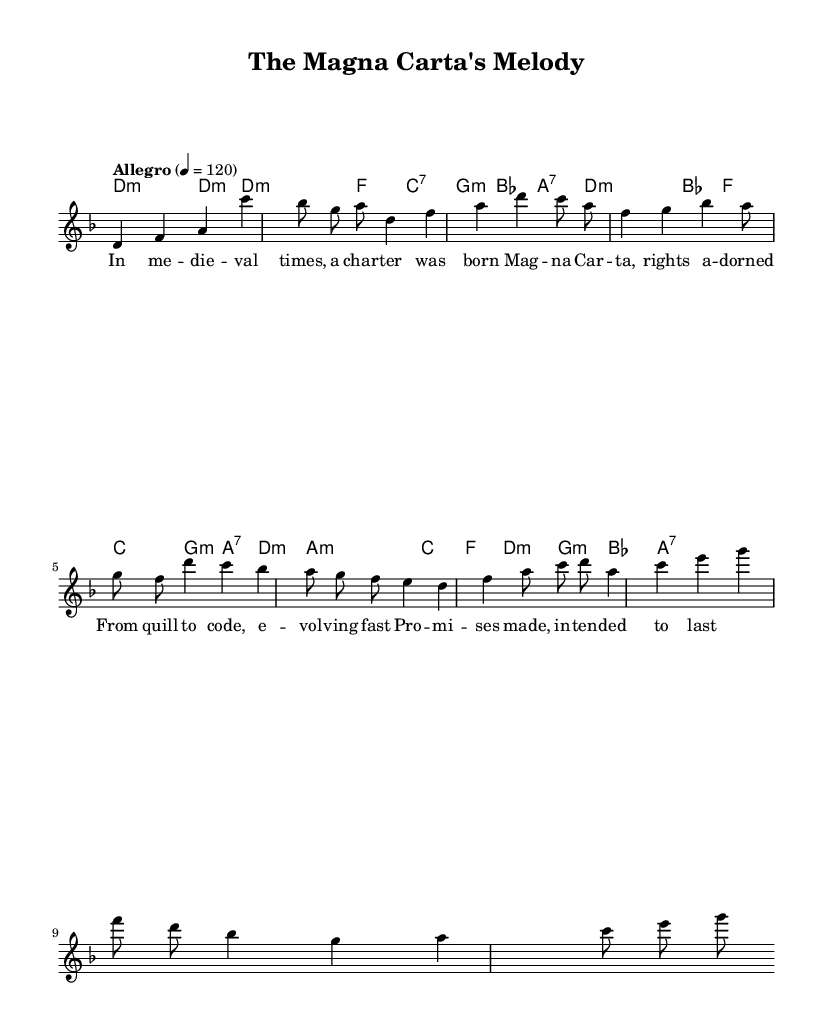What is the key signature of this music? The key signature is indicated at the beginning of the score, showing one flat, which corresponds to D minor.
Answer: D minor What is the time signature of the piece? The time signature is displayed near the beginning, indicating the piece is in a 7/8 time signature.
Answer: 7/8 What is the tempo marking for the music? The tempo marking shows that the piece should be played "Allegro" at a speed of 120 beats per minute.
Answer: Allegro 4 = 120 How many measures are in the melody section? Counting the measures within the melody section as visually represented in the sheet music, there are a total of 8 measures.
Answer: 8 What type of fusion represents the genre of this sheet music? The genre described is a combination of progressive rock and folk music, often characterized by intricate rhythms and melodic storytelling.
Answer: Progressive rock-folk fusion Identify the first note of the melody. The first note of the melody, as indicated on the first staff, is D in the fourth octave.
Answer: D What lyrical theme does the chorus address? The lyrics in the chorus suggest themes of evolution and the permanence of promises, reflecting the historic development of contract law.
Answer: Evolution of contracts 